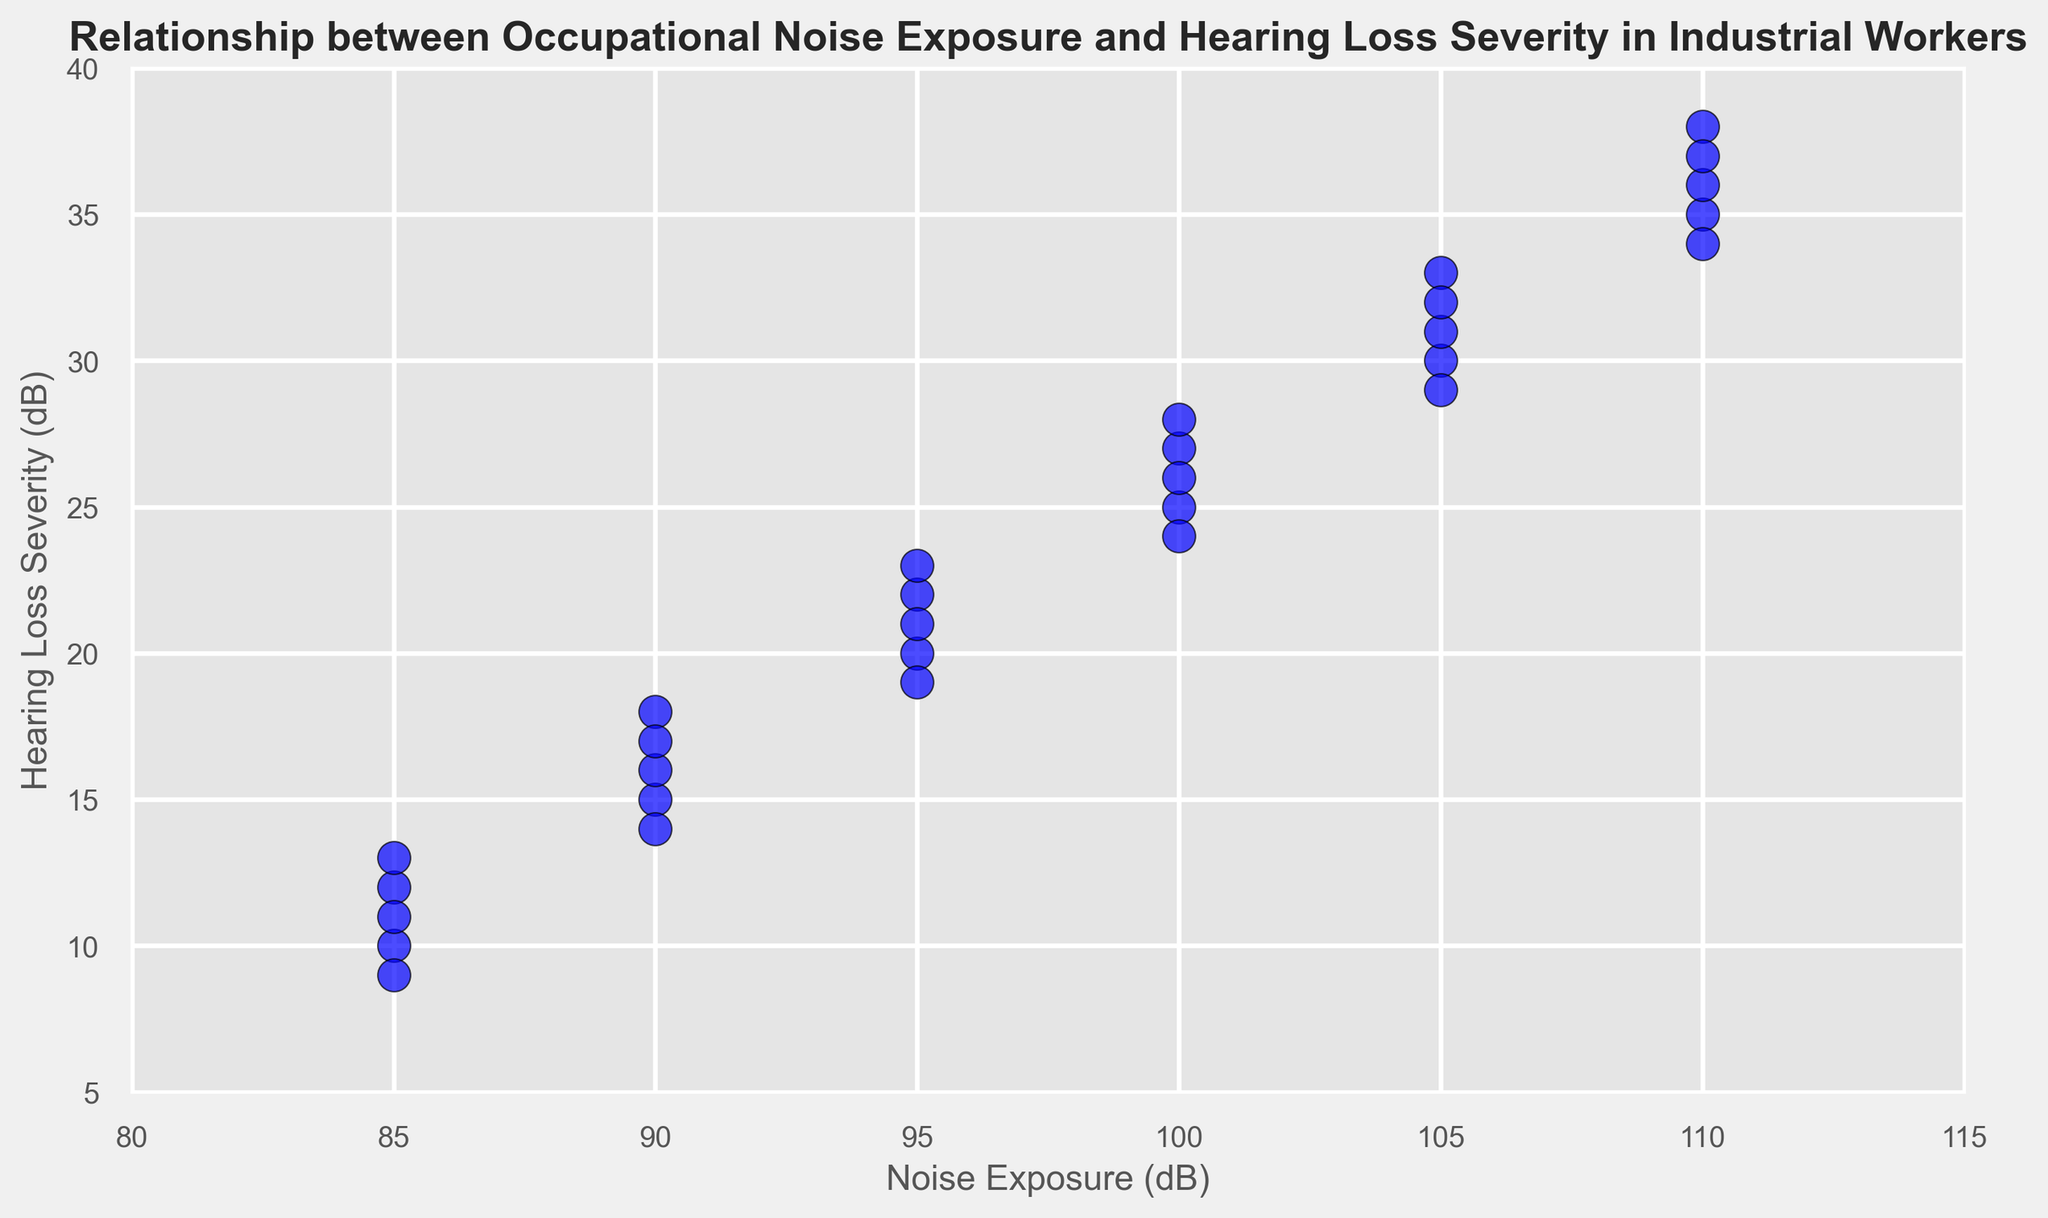What is the range of Hearing Loss Severity in Industrial Workers exposed to 85 dB of noise? First, identify all the points where Noise Exposure is 85 dB. The Hearing Loss Severity values are 10, 12, 11, and 13. The range is the difference between the maximum and minimum of these values (13 - 10).
Answer: 3 Which noise exposure level has the highest average Hearing Loss Severity? Find the average Hearing Loss Severity for each noise exposure level: for example, for 85 dB: (10 + 12 + 11 + 13 + 9)/5 = 11; repeat for the other noise levels and compare the averages to find the maximum. Here, 110 dB has an average severity of (35 + 38 + 34 + 36 + 37)/5 = 36
Answer: 110 dB Do workers exposed to 100 dB always exhibit higher Hearing Loss Severity than those exposed to 85 dB? Compare each data point for 85 dB (10, 12, 11, 13, 9) with those for 100 dB (25, 27, 26, 28, 24). While the range of Hearing Loss Severity for 85 dB is between 9 and 13, the range for 100 dB is between 24 and 28, showing that all values at 100 dB are higher.
Answer: Yes What is the median Hearing Loss Severity for exposure at 90 dB and at 95 dB? Extract the values for 90 dB (15, 16, 14, 18, 17) and 95 dB (20, 22, 19, 23, 21). For 90 dB, order them to get: 14, 15, 16, 17, 18; the median is 16. For 95 dB order them to get: 19, 20, 21, 22, 23; the median is 21.
Answer: 16 for 90 dB, 21 for 95 dB If noise exposure increases from 85 dB to 95 dB, how much does the average Hearing Loss Severity increase? Calculate the average Hearing Loss Severity for 85 dB: (10+12+11+13+9)/5 = 11; and for 95 dB: (20+22+19+23+21)/5 = 21. The increase is 21 - 11.
Answer: 10 Are the data points for each Noise Exposure level represented with a specific color, size, or marker style? All data points are marked with blue circles having a black edge, indicating they do not differ in style by noise exposure levels.
Answer: No Is there any noise exposure level where the range of Hearing Loss Severity is larger than 10 dB? Compare the ranges for each noise exposure level. None of the ranges exceed 10 dB, with the maximum being 9 dB for 110 dB (38 - 29).
Answer: No Does any noise exposure level show an overlap in Hearing Loss Severity with the next higher or lower level? Compare Hearing Loss Severity ranges for adjacent noise levels: e.g., 85 dB (9-13) and 90 dB (14-18) have no overlap, nor do 90 dB (14-18) and 95 dB (19-23). Repeat for others; no overlaps found.
Answer: No 